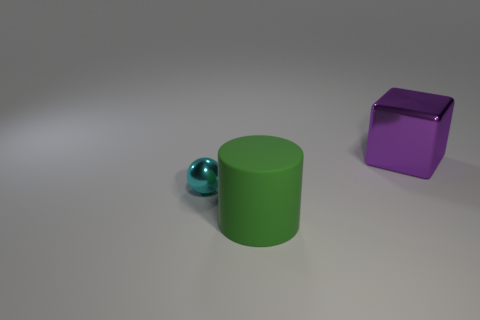What mood or atmosphere does the lighting in the scene convey? The lighting in the scene is soft and diffused, creating a calm and neutral atmosphere. There are no harsh shadows or bright highlights, which contributes to a very composed and undramatic mood. It feels like a controlled environment, possibly used for product showcasing. 